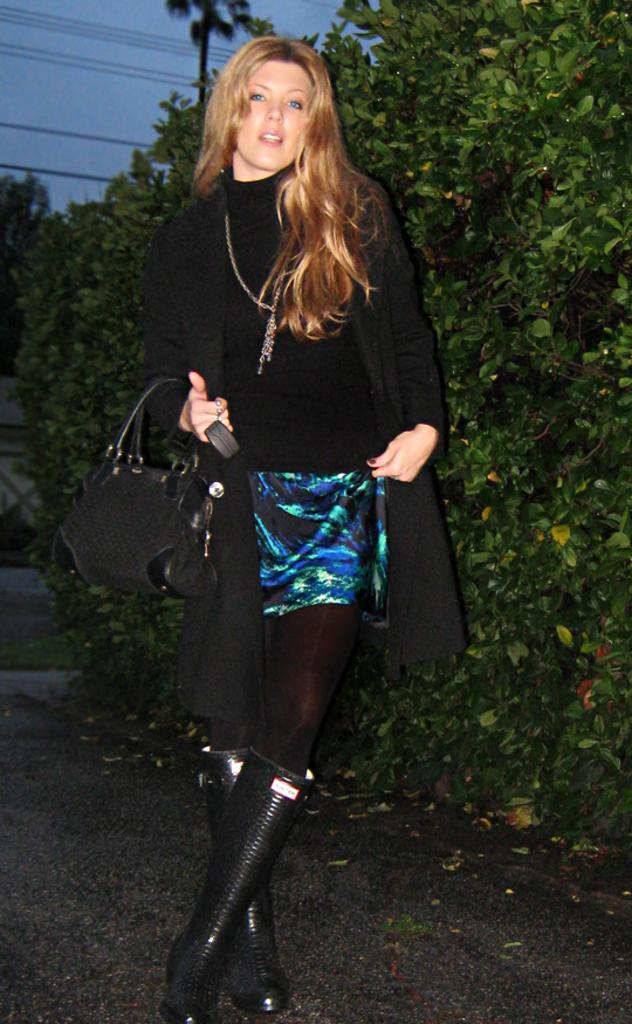Who is the main subject in the image? There is a woman in the image. What is the woman wearing? The woman is dressed for a party. What is the woman holding in the image? The woman is holding a bag. What can be seen in the background of the image? There are green bushes and trees, as well as cables running along. What type of wound can be seen on the chicken in the image? There is no chicken present in the image, and therefore no wound can be observed. 